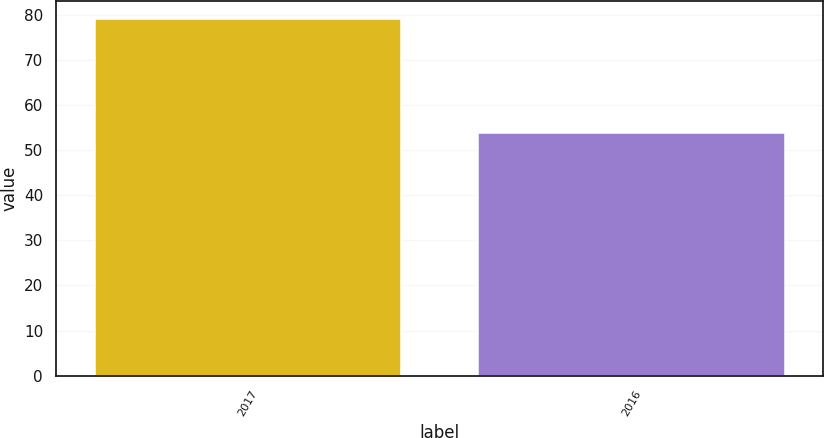Convert chart to OTSL. <chart><loc_0><loc_0><loc_500><loc_500><bar_chart><fcel>2017<fcel>2016<nl><fcel>79.06<fcel>53.88<nl></chart> 